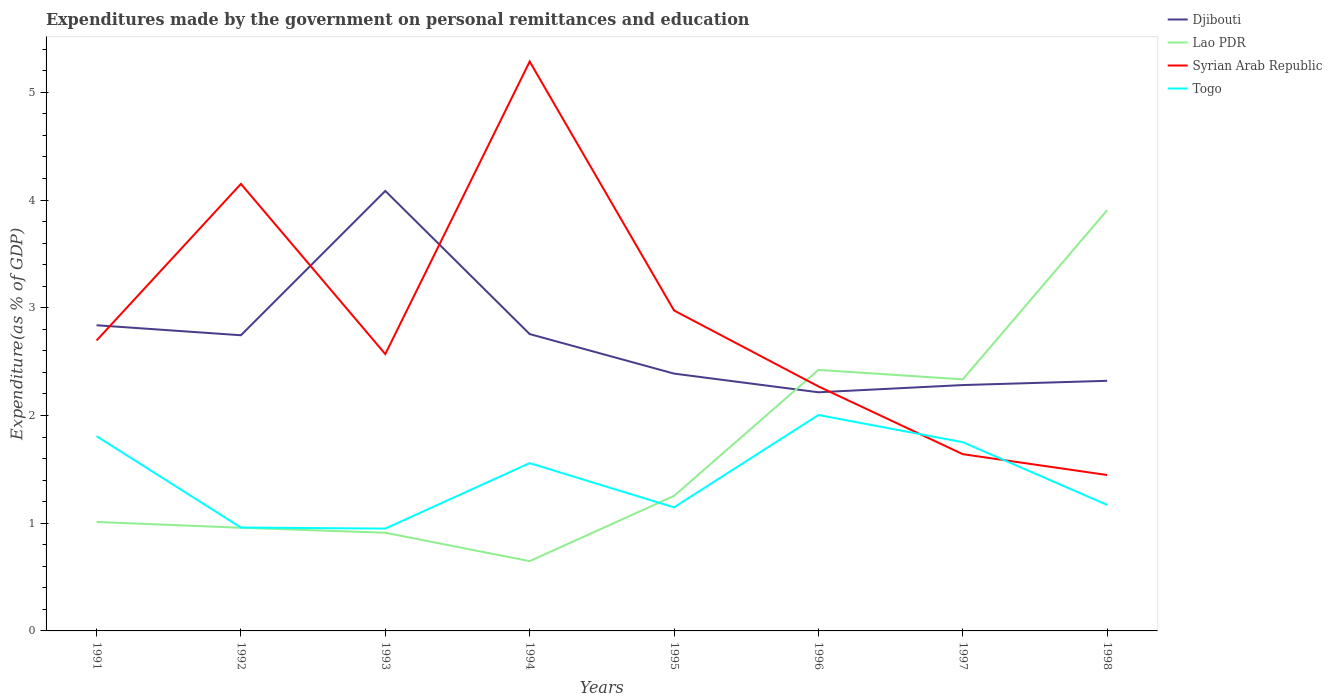How many different coloured lines are there?
Offer a terse response. 4. Across all years, what is the maximum expenditures made by the government on personal remittances and education in Djibouti?
Your response must be concise. 2.22. In which year was the expenditures made by the government on personal remittances and education in Syrian Arab Republic maximum?
Give a very brief answer. 1998. What is the total expenditures made by the government on personal remittances and education in Djibouti in the graph?
Provide a succinct answer. -0.01. What is the difference between the highest and the second highest expenditures made by the government on personal remittances and education in Syrian Arab Republic?
Keep it short and to the point. 3.84. What is the difference between the highest and the lowest expenditures made by the government on personal remittances and education in Togo?
Your answer should be compact. 4. Does the graph contain any zero values?
Keep it short and to the point. No. Where does the legend appear in the graph?
Keep it short and to the point. Top right. How are the legend labels stacked?
Offer a very short reply. Vertical. What is the title of the graph?
Make the answer very short. Expenditures made by the government on personal remittances and education. What is the label or title of the X-axis?
Provide a succinct answer. Years. What is the label or title of the Y-axis?
Your answer should be compact. Expenditure(as % of GDP). What is the Expenditure(as % of GDP) of Djibouti in 1991?
Make the answer very short. 2.84. What is the Expenditure(as % of GDP) of Lao PDR in 1991?
Make the answer very short. 1.01. What is the Expenditure(as % of GDP) of Syrian Arab Republic in 1991?
Offer a terse response. 2.7. What is the Expenditure(as % of GDP) of Togo in 1991?
Offer a very short reply. 1.81. What is the Expenditure(as % of GDP) of Djibouti in 1992?
Your answer should be compact. 2.74. What is the Expenditure(as % of GDP) of Lao PDR in 1992?
Your response must be concise. 0.96. What is the Expenditure(as % of GDP) of Syrian Arab Republic in 1992?
Offer a terse response. 4.15. What is the Expenditure(as % of GDP) in Togo in 1992?
Provide a short and direct response. 0.96. What is the Expenditure(as % of GDP) in Djibouti in 1993?
Offer a terse response. 4.08. What is the Expenditure(as % of GDP) in Lao PDR in 1993?
Make the answer very short. 0.91. What is the Expenditure(as % of GDP) of Syrian Arab Republic in 1993?
Your response must be concise. 2.57. What is the Expenditure(as % of GDP) in Togo in 1993?
Make the answer very short. 0.95. What is the Expenditure(as % of GDP) in Djibouti in 1994?
Your answer should be very brief. 2.76. What is the Expenditure(as % of GDP) of Lao PDR in 1994?
Keep it short and to the point. 0.65. What is the Expenditure(as % of GDP) in Syrian Arab Republic in 1994?
Offer a terse response. 5.29. What is the Expenditure(as % of GDP) in Togo in 1994?
Offer a very short reply. 1.56. What is the Expenditure(as % of GDP) of Djibouti in 1995?
Your answer should be compact. 2.39. What is the Expenditure(as % of GDP) in Lao PDR in 1995?
Your response must be concise. 1.25. What is the Expenditure(as % of GDP) of Syrian Arab Republic in 1995?
Provide a succinct answer. 2.97. What is the Expenditure(as % of GDP) of Togo in 1995?
Your response must be concise. 1.15. What is the Expenditure(as % of GDP) of Djibouti in 1996?
Ensure brevity in your answer.  2.22. What is the Expenditure(as % of GDP) of Lao PDR in 1996?
Give a very brief answer. 2.42. What is the Expenditure(as % of GDP) in Syrian Arab Republic in 1996?
Keep it short and to the point. 2.27. What is the Expenditure(as % of GDP) of Togo in 1996?
Make the answer very short. 2. What is the Expenditure(as % of GDP) in Djibouti in 1997?
Your answer should be very brief. 2.28. What is the Expenditure(as % of GDP) of Lao PDR in 1997?
Your response must be concise. 2.34. What is the Expenditure(as % of GDP) of Syrian Arab Republic in 1997?
Provide a short and direct response. 1.64. What is the Expenditure(as % of GDP) of Togo in 1997?
Offer a very short reply. 1.75. What is the Expenditure(as % of GDP) in Djibouti in 1998?
Provide a succinct answer. 2.32. What is the Expenditure(as % of GDP) in Lao PDR in 1998?
Give a very brief answer. 3.91. What is the Expenditure(as % of GDP) of Syrian Arab Republic in 1998?
Make the answer very short. 1.45. What is the Expenditure(as % of GDP) in Togo in 1998?
Make the answer very short. 1.17. Across all years, what is the maximum Expenditure(as % of GDP) in Djibouti?
Ensure brevity in your answer.  4.08. Across all years, what is the maximum Expenditure(as % of GDP) in Lao PDR?
Make the answer very short. 3.91. Across all years, what is the maximum Expenditure(as % of GDP) of Syrian Arab Republic?
Your answer should be compact. 5.29. Across all years, what is the maximum Expenditure(as % of GDP) in Togo?
Make the answer very short. 2. Across all years, what is the minimum Expenditure(as % of GDP) in Djibouti?
Provide a short and direct response. 2.22. Across all years, what is the minimum Expenditure(as % of GDP) of Lao PDR?
Ensure brevity in your answer.  0.65. Across all years, what is the minimum Expenditure(as % of GDP) of Syrian Arab Republic?
Provide a succinct answer. 1.45. Across all years, what is the minimum Expenditure(as % of GDP) in Togo?
Provide a short and direct response. 0.95. What is the total Expenditure(as % of GDP) in Djibouti in the graph?
Offer a very short reply. 21.63. What is the total Expenditure(as % of GDP) in Lao PDR in the graph?
Provide a short and direct response. 13.45. What is the total Expenditure(as % of GDP) in Syrian Arab Republic in the graph?
Offer a very short reply. 23.03. What is the total Expenditure(as % of GDP) in Togo in the graph?
Offer a terse response. 11.35. What is the difference between the Expenditure(as % of GDP) of Djibouti in 1991 and that in 1992?
Your answer should be compact. 0.09. What is the difference between the Expenditure(as % of GDP) in Lao PDR in 1991 and that in 1992?
Your response must be concise. 0.05. What is the difference between the Expenditure(as % of GDP) of Syrian Arab Republic in 1991 and that in 1992?
Give a very brief answer. -1.45. What is the difference between the Expenditure(as % of GDP) in Togo in 1991 and that in 1992?
Provide a short and direct response. 0.85. What is the difference between the Expenditure(as % of GDP) of Djibouti in 1991 and that in 1993?
Offer a very short reply. -1.25. What is the difference between the Expenditure(as % of GDP) in Lao PDR in 1991 and that in 1993?
Provide a short and direct response. 0.1. What is the difference between the Expenditure(as % of GDP) of Syrian Arab Republic in 1991 and that in 1993?
Offer a terse response. 0.13. What is the difference between the Expenditure(as % of GDP) of Togo in 1991 and that in 1993?
Your response must be concise. 0.86. What is the difference between the Expenditure(as % of GDP) in Djibouti in 1991 and that in 1994?
Ensure brevity in your answer.  0.08. What is the difference between the Expenditure(as % of GDP) in Lao PDR in 1991 and that in 1994?
Provide a short and direct response. 0.36. What is the difference between the Expenditure(as % of GDP) of Syrian Arab Republic in 1991 and that in 1994?
Your response must be concise. -2.59. What is the difference between the Expenditure(as % of GDP) of Togo in 1991 and that in 1994?
Ensure brevity in your answer.  0.25. What is the difference between the Expenditure(as % of GDP) of Djibouti in 1991 and that in 1995?
Offer a terse response. 0.45. What is the difference between the Expenditure(as % of GDP) of Lao PDR in 1991 and that in 1995?
Offer a very short reply. -0.24. What is the difference between the Expenditure(as % of GDP) of Syrian Arab Republic in 1991 and that in 1995?
Offer a terse response. -0.28. What is the difference between the Expenditure(as % of GDP) of Togo in 1991 and that in 1995?
Give a very brief answer. 0.66. What is the difference between the Expenditure(as % of GDP) of Djibouti in 1991 and that in 1996?
Give a very brief answer. 0.62. What is the difference between the Expenditure(as % of GDP) in Lao PDR in 1991 and that in 1996?
Provide a short and direct response. -1.41. What is the difference between the Expenditure(as % of GDP) of Syrian Arab Republic in 1991 and that in 1996?
Provide a short and direct response. 0.43. What is the difference between the Expenditure(as % of GDP) in Togo in 1991 and that in 1996?
Give a very brief answer. -0.2. What is the difference between the Expenditure(as % of GDP) of Djibouti in 1991 and that in 1997?
Give a very brief answer. 0.56. What is the difference between the Expenditure(as % of GDP) in Lao PDR in 1991 and that in 1997?
Your answer should be very brief. -1.32. What is the difference between the Expenditure(as % of GDP) of Syrian Arab Republic in 1991 and that in 1997?
Provide a short and direct response. 1.06. What is the difference between the Expenditure(as % of GDP) in Togo in 1991 and that in 1997?
Give a very brief answer. 0.06. What is the difference between the Expenditure(as % of GDP) of Djibouti in 1991 and that in 1998?
Your response must be concise. 0.52. What is the difference between the Expenditure(as % of GDP) of Lao PDR in 1991 and that in 1998?
Your answer should be very brief. -2.89. What is the difference between the Expenditure(as % of GDP) in Syrian Arab Republic in 1991 and that in 1998?
Provide a short and direct response. 1.25. What is the difference between the Expenditure(as % of GDP) in Togo in 1991 and that in 1998?
Make the answer very short. 0.64. What is the difference between the Expenditure(as % of GDP) in Djibouti in 1992 and that in 1993?
Offer a terse response. -1.34. What is the difference between the Expenditure(as % of GDP) in Lao PDR in 1992 and that in 1993?
Your response must be concise. 0.05. What is the difference between the Expenditure(as % of GDP) in Syrian Arab Republic in 1992 and that in 1993?
Offer a very short reply. 1.58. What is the difference between the Expenditure(as % of GDP) in Togo in 1992 and that in 1993?
Offer a very short reply. 0.01. What is the difference between the Expenditure(as % of GDP) of Djibouti in 1992 and that in 1994?
Your response must be concise. -0.01. What is the difference between the Expenditure(as % of GDP) of Lao PDR in 1992 and that in 1994?
Offer a very short reply. 0.31. What is the difference between the Expenditure(as % of GDP) of Syrian Arab Republic in 1992 and that in 1994?
Give a very brief answer. -1.14. What is the difference between the Expenditure(as % of GDP) in Togo in 1992 and that in 1994?
Make the answer very short. -0.6. What is the difference between the Expenditure(as % of GDP) in Djibouti in 1992 and that in 1995?
Your answer should be very brief. 0.36. What is the difference between the Expenditure(as % of GDP) of Lao PDR in 1992 and that in 1995?
Your answer should be compact. -0.3. What is the difference between the Expenditure(as % of GDP) of Syrian Arab Republic in 1992 and that in 1995?
Offer a very short reply. 1.18. What is the difference between the Expenditure(as % of GDP) of Togo in 1992 and that in 1995?
Your answer should be compact. -0.19. What is the difference between the Expenditure(as % of GDP) of Djibouti in 1992 and that in 1996?
Offer a very short reply. 0.53. What is the difference between the Expenditure(as % of GDP) of Lao PDR in 1992 and that in 1996?
Give a very brief answer. -1.47. What is the difference between the Expenditure(as % of GDP) in Syrian Arab Republic in 1992 and that in 1996?
Offer a very short reply. 1.88. What is the difference between the Expenditure(as % of GDP) of Togo in 1992 and that in 1996?
Your response must be concise. -1.04. What is the difference between the Expenditure(as % of GDP) in Djibouti in 1992 and that in 1997?
Your answer should be very brief. 0.46. What is the difference between the Expenditure(as % of GDP) of Lao PDR in 1992 and that in 1997?
Keep it short and to the point. -1.38. What is the difference between the Expenditure(as % of GDP) in Syrian Arab Republic in 1992 and that in 1997?
Your answer should be very brief. 2.51. What is the difference between the Expenditure(as % of GDP) of Togo in 1992 and that in 1997?
Provide a short and direct response. -0.79. What is the difference between the Expenditure(as % of GDP) in Djibouti in 1992 and that in 1998?
Provide a succinct answer. 0.42. What is the difference between the Expenditure(as % of GDP) in Lao PDR in 1992 and that in 1998?
Make the answer very short. -2.95. What is the difference between the Expenditure(as % of GDP) of Syrian Arab Republic in 1992 and that in 1998?
Your response must be concise. 2.7. What is the difference between the Expenditure(as % of GDP) of Togo in 1992 and that in 1998?
Make the answer very short. -0.21. What is the difference between the Expenditure(as % of GDP) in Djibouti in 1993 and that in 1994?
Your answer should be compact. 1.33. What is the difference between the Expenditure(as % of GDP) of Lao PDR in 1993 and that in 1994?
Give a very brief answer. 0.26. What is the difference between the Expenditure(as % of GDP) of Syrian Arab Republic in 1993 and that in 1994?
Ensure brevity in your answer.  -2.72. What is the difference between the Expenditure(as % of GDP) of Togo in 1993 and that in 1994?
Give a very brief answer. -0.61. What is the difference between the Expenditure(as % of GDP) in Djibouti in 1993 and that in 1995?
Your answer should be compact. 1.7. What is the difference between the Expenditure(as % of GDP) in Lao PDR in 1993 and that in 1995?
Make the answer very short. -0.34. What is the difference between the Expenditure(as % of GDP) of Syrian Arab Republic in 1993 and that in 1995?
Your answer should be compact. -0.4. What is the difference between the Expenditure(as % of GDP) in Togo in 1993 and that in 1995?
Give a very brief answer. -0.2. What is the difference between the Expenditure(as % of GDP) of Djibouti in 1993 and that in 1996?
Your answer should be compact. 1.87. What is the difference between the Expenditure(as % of GDP) in Lao PDR in 1993 and that in 1996?
Offer a terse response. -1.51. What is the difference between the Expenditure(as % of GDP) in Syrian Arab Republic in 1993 and that in 1996?
Your answer should be compact. 0.3. What is the difference between the Expenditure(as % of GDP) of Togo in 1993 and that in 1996?
Make the answer very short. -1.05. What is the difference between the Expenditure(as % of GDP) of Djibouti in 1993 and that in 1997?
Your answer should be very brief. 1.8. What is the difference between the Expenditure(as % of GDP) in Lao PDR in 1993 and that in 1997?
Your answer should be compact. -1.42. What is the difference between the Expenditure(as % of GDP) in Syrian Arab Republic in 1993 and that in 1997?
Offer a terse response. 0.93. What is the difference between the Expenditure(as % of GDP) in Togo in 1993 and that in 1997?
Ensure brevity in your answer.  -0.8. What is the difference between the Expenditure(as % of GDP) in Djibouti in 1993 and that in 1998?
Ensure brevity in your answer.  1.76. What is the difference between the Expenditure(as % of GDP) in Lao PDR in 1993 and that in 1998?
Offer a very short reply. -2.99. What is the difference between the Expenditure(as % of GDP) of Syrian Arab Republic in 1993 and that in 1998?
Make the answer very short. 1.12. What is the difference between the Expenditure(as % of GDP) in Togo in 1993 and that in 1998?
Ensure brevity in your answer.  -0.22. What is the difference between the Expenditure(as % of GDP) in Djibouti in 1994 and that in 1995?
Make the answer very short. 0.37. What is the difference between the Expenditure(as % of GDP) of Lao PDR in 1994 and that in 1995?
Keep it short and to the point. -0.61. What is the difference between the Expenditure(as % of GDP) of Syrian Arab Republic in 1994 and that in 1995?
Give a very brief answer. 2.31. What is the difference between the Expenditure(as % of GDP) in Togo in 1994 and that in 1995?
Your response must be concise. 0.41. What is the difference between the Expenditure(as % of GDP) of Djibouti in 1994 and that in 1996?
Provide a short and direct response. 0.54. What is the difference between the Expenditure(as % of GDP) in Lao PDR in 1994 and that in 1996?
Ensure brevity in your answer.  -1.78. What is the difference between the Expenditure(as % of GDP) in Syrian Arab Republic in 1994 and that in 1996?
Offer a terse response. 3.02. What is the difference between the Expenditure(as % of GDP) of Togo in 1994 and that in 1996?
Your answer should be very brief. -0.45. What is the difference between the Expenditure(as % of GDP) in Djibouti in 1994 and that in 1997?
Provide a short and direct response. 0.47. What is the difference between the Expenditure(as % of GDP) in Lao PDR in 1994 and that in 1997?
Offer a terse response. -1.69. What is the difference between the Expenditure(as % of GDP) of Syrian Arab Republic in 1994 and that in 1997?
Offer a very short reply. 3.64. What is the difference between the Expenditure(as % of GDP) of Togo in 1994 and that in 1997?
Your answer should be compact. -0.19. What is the difference between the Expenditure(as % of GDP) of Djibouti in 1994 and that in 1998?
Ensure brevity in your answer.  0.43. What is the difference between the Expenditure(as % of GDP) of Lao PDR in 1994 and that in 1998?
Offer a very short reply. -3.26. What is the difference between the Expenditure(as % of GDP) of Syrian Arab Republic in 1994 and that in 1998?
Make the answer very short. 3.84. What is the difference between the Expenditure(as % of GDP) in Togo in 1994 and that in 1998?
Offer a terse response. 0.39. What is the difference between the Expenditure(as % of GDP) in Djibouti in 1995 and that in 1996?
Offer a terse response. 0.17. What is the difference between the Expenditure(as % of GDP) of Lao PDR in 1995 and that in 1996?
Your response must be concise. -1.17. What is the difference between the Expenditure(as % of GDP) in Syrian Arab Republic in 1995 and that in 1996?
Your answer should be very brief. 0.7. What is the difference between the Expenditure(as % of GDP) in Togo in 1995 and that in 1996?
Offer a very short reply. -0.86. What is the difference between the Expenditure(as % of GDP) in Djibouti in 1995 and that in 1997?
Keep it short and to the point. 0.11. What is the difference between the Expenditure(as % of GDP) of Lao PDR in 1995 and that in 1997?
Give a very brief answer. -1.08. What is the difference between the Expenditure(as % of GDP) in Syrian Arab Republic in 1995 and that in 1997?
Offer a very short reply. 1.33. What is the difference between the Expenditure(as % of GDP) in Togo in 1995 and that in 1997?
Give a very brief answer. -0.6. What is the difference between the Expenditure(as % of GDP) of Djibouti in 1995 and that in 1998?
Offer a terse response. 0.07. What is the difference between the Expenditure(as % of GDP) in Lao PDR in 1995 and that in 1998?
Your answer should be compact. -2.65. What is the difference between the Expenditure(as % of GDP) of Syrian Arab Republic in 1995 and that in 1998?
Provide a short and direct response. 1.53. What is the difference between the Expenditure(as % of GDP) in Togo in 1995 and that in 1998?
Provide a short and direct response. -0.02. What is the difference between the Expenditure(as % of GDP) of Djibouti in 1996 and that in 1997?
Offer a terse response. -0.07. What is the difference between the Expenditure(as % of GDP) in Lao PDR in 1996 and that in 1997?
Provide a succinct answer. 0.09. What is the difference between the Expenditure(as % of GDP) of Syrian Arab Republic in 1996 and that in 1997?
Your answer should be very brief. 0.63. What is the difference between the Expenditure(as % of GDP) of Togo in 1996 and that in 1997?
Your answer should be compact. 0.25. What is the difference between the Expenditure(as % of GDP) in Djibouti in 1996 and that in 1998?
Make the answer very short. -0.11. What is the difference between the Expenditure(as % of GDP) of Lao PDR in 1996 and that in 1998?
Make the answer very short. -1.48. What is the difference between the Expenditure(as % of GDP) of Syrian Arab Republic in 1996 and that in 1998?
Your answer should be compact. 0.82. What is the difference between the Expenditure(as % of GDP) in Togo in 1996 and that in 1998?
Your answer should be compact. 0.83. What is the difference between the Expenditure(as % of GDP) of Djibouti in 1997 and that in 1998?
Ensure brevity in your answer.  -0.04. What is the difference between the Expenditure(as % of GDP) of Lao PDR in 1997 and that in 1998?
Give a very brief answer. -1.57. What is the difference between the Expenditure(as % of GDP) in Syrian Arab Republic in 1997 and that in 1998?
Ensure brevity in your answer.  0.19. What is the difference between the Expenditure(as % of GDP) of Togo in 1997 and that in 1998?
Ensure brevity in your answer.  0.58. What is the difference between the Expenditure(as % of GDP) of Djibouti in 1991 and the Expenditure(as % of GDP) of Lao PDR in 1992?
Offer a terse response. 1.88. What is the difference between the Expenditure(as % of GDP) of Djibouti in 1991 and the Expenditure(as % of GDP) of Syrian Arab Republic in 1992?
Ensure brevity in your answer.  -1.31. What is the difference between the Expenditure(as % of GDP) in Djibouti in 1991 and the Expenditure(as % of GDP) in Togo in 1992?
Your answer should be very brief. 1.88. What is the difference between the Expenditure(as % of GDP) of Lao PDR in 1991 and the Expenditure(as % of GDP) of Syrian Arab Republic in 1992?
Offer a terse response. -3.14. What is the difference between the Expenditure(as % of GDP) in Lao PDR in 1991 and the Expenditure(as % of GDP) in Togo in 1992?
Your answer should be very brief. 0.05. What is the difference between the Expenditure(as % of GDP) of Syrian Arab Republic in 1991 and the Expenditure(as % of GDP) of Togo in 1992?
Provide a succinct answer. 1.74. What is the difference between the Expenditure(as % of GDP) in Djibouti in 1991 and the Expenditure(as % of GDP) in Lao PDR in 1993?
Your answer should be compact. 1.93. What is the difference between the Expenditure(as % of GDP) of Djibouti in 1991 and the Expenditure(as % of GDP) of Syrian Arab Republic in 1993?
Your answer should be very brief. 0.27. What is the difference between the Expenditure(as % of GDP) of Djibouti in 1991 and the Expenditure(as % of GDP) of Togo in 1993?
Give a very brief answer. 1.89. What is the difference between the Expenditure(as % of GDP) in Lao PDR in 1991 and the Expenditure(as % of GDP) in Syrian Arab Republic in 1993?
Keep it short and to the point. -1.56. What is the difference between the Expenditure(as % of GDP) in Lao PDR in 1991 and the Expenditure(as % of GDP) in Togo in 1993?
Your answer should be very brief. 0.06. What is the difference between the Expenditure(as % of GDP) in Syrian Arab Republic in 1991 and the Expenditure(as % of GDP) in Togo in 1993?
Provide a short and direct response. 1.75. What is the difference between the Expenditure(as % of GDP) in Djibouti in 1991 and the Expenditure(as % of GDP) in Lao PDR in 1994?
Provide a succinct answer. 2.19. What is the difference between the Expenditure(as % of GDP) of Djibouti in 1991 and the Expenditure(as % of GDP) of Syrian Arab Republic in 1994?
Offer a terse response. -2.45. What is the difference between the Expenditure(as % of GDP) of Djibouti in 1991 and the Expenditure(as % of GDP) of Togo in 1994?
Provide a succinct answer. 1.28. What is the difference between the Expenditure(as % of GDP) in Lao PDR in 1991 and the Expenditure(as % of GDP) in Syrian Arab Republic in 1994?
Offer a very short reply. -4.27. What is the difference between the Expenditure(as % of GDP) in Lao PDR in 1991 and the Expenditure(as % of GDP) in Togo in 1994?
Your response must be concise. -0.55. What is the difference between the Expenditure(as % of GDP) of Syrian Arab Republic in 1991 and the Expenditure(as % of GDP) of Togo in 1994?
Provide a succinct answer. 1.14. What is the difference between the Expenditure(as % of GDP) of Djibouti in 1991 and the Expenditure(as % of GDP) of Lao PDR in 1995?
Give a very brief answer. 1.58. What is the difference between the Expenditure(as % of GDP) of Djibouti in 1991 and the Expenditure(as % of GDP) of Syrian Arab Republic in 1995?
Ensure brevity in your answer.  -0.14. What is the difference between the Expenditure(as % of GDP) in Djibouti in 1991 and the Expenditure(as % of GDP) in Togo in 1995?
Offer a terse response. 1.69. What is the difference between the Expenditure(as % of GDP) of Lao PDR in 1991 and the Expenditure(as % of GDP) of Syrian Arab Republic in 1995?
Keep it short and to the point. -1.96. What is the difference between the Expenditure(as % of GDP) in Lao PDR in 1991 and the Expenditure(as % of GDP) in Togo in 1995?
Make the answer very short. -0.14. What is the difference between the Expenditure(as % of GDP) of Syrian Arab Republic in 1991 and the Expenditure(as % of GDP) of Togo in 1995?
Ensure brevity in your answer.  1.55. What is the difference between the Expenditure(as % of GDP) of Djibouti in 1991 and the Expenditure(as % of GDP) of Lao PDR in 1996?
Keep it short and to the point. 0.41. What is the difference between the Expenditure(as % of GDP) of Djibouti in 1991 and the Expenditure(as % of GDP) of Syrian Arab Republic in 1996?
Your answer should be compact. 0.57. What is the difference between the Expenditure(as % of GDP) in Lao PDR in 1991 and the Expenditure(as % of GDP) in Syrian Arab Republic in 1996?
Make the answer very short. -1.26. What is the difference between the Expenditure(as % of GDP) in Lao PDR in 1991 and the Expenditure(as % of GDP) in Togo in 1996?
Offer a very short reply. -0.99. What is the difference between the Expenditure(as % of GDP) of Syrian Arab Republic in 1991 and the Expenditure(as % of GDP) of Togo in 1996?
Provide a succinct answer. 0.69. What is the difference between the Expenditure(as % of GDP) of Djibouti in 1991 and the Expenditure(as % of GDP) of Lao PDR in 1997?
Make the answer very short. 0.5. What is the difference between the Expenditure(as % of GDP) in Djibouti in 1991 and the Expenditure(as % of GDP) in Syrian Arab Republic in 1997?
Keep it short and to the point. 1.2. What is the difference between the Expenditure(as % of GDP) of Djibouti in 1991 and the Expenditure(as % of GDP) of Togo in 1997?
Your answer should be compact. 1.09. What is the difference between the Expenditure(as % of GDP) in Lao PDR in 1991 and the Expenditure(as % of GDP) in Syrian Arab Republic in 1997?
Make the answer very short. -0.63. What is the difference between the Expenditure(as % of GDP) of Lao PDR in 1991 and the Expenditure(as % of GDP) of Togo in 1997?
Offer a terse response. -0.74. What is the difference between the Expenditure(as % of GDP) of Syrian Arab Republic in 1991 and the Expenditure(as % of GDP) of Togo in 1997?
Ensure brevity in your answer.  0.94. What is the difference between the Expenditure(as % of GDP) in Djibouti in 1991 and the Expenditure(as % of GDP) in Lao PDR in 1998?
Your response must be concise. -1.07. What is the difference between the Expenditure(as % of GDP) in Djibouti in 1991 and the Expenditure(as % of GDP) in Syrian Arab Republic in 1998?
Offer a terse response. 1.39. What is the difference between the Expenditure(as % of GDP) in Djibouti in 1991 and the Expenditure(as % of GDP) in Togo in 1998?
Your response must be concise. 1.67. What is the difference between the Expenditure(as % of GDP) in Lao PDR in 1991 and the Expenditure(as % of GDP) in Syrian Arab Republic in 1998?
Provide a short and direct response. -0.44. What is the difference between the Expenditure(as % of GDP) of Lao PDR in 1991 and the Expenditure(as % of GDP) of Togo in 1998?
Provide a succinct answer. -0.16. What is the difference between the Expenditure(as % of GDP) in Syrian Arab Republic in 1991 and the Expenditure(as % of GDP) in Togo in 1998?
Provide a succinct answer. 1.53. What is the difference between the Expenditure(as % of GDP) in Djibouti in 1992 and the Expenditure(as % of GDP) in Lao PDR in 1993?
Provide a short and direct response. 1.83. What is the difference between the Expenditure(as % of GDP) in Djibouti in 1992 and the Expenditure(as % of GDP) in Syrian Arab Republic in 1993?
Offer a very short reply. 0.17. What is the difference between the Expenditure(as % of GDP) in Djibouti in 1992 and the Expenditure(as % of GDP) in Togo in 1993?
Keep it short and to the point. 1.79. What is the difference between the Expenditure(as % of GDP) of Lao PDR in 1992 and the Expenditure(as % of GDP) of Syrian Arab Republic in 1993?
Ensure brevity in your answer.  -1.61. What is the difference between the Expenditure(as % of GDP) in Lao PDR in 1992 and the Expenditure(as % of GDP) in Togo in 1993?
Offer a terse response. 0.01. What is the difference between the Expenditure(as % of GDP) of Syrian Arab Republic in 1992 and the Expenditure(as % of GDP) of Togo in 1993?
Your answer should be very brief. 3.2. What is the difference between the Expenditure(as % of GDP) of Djibouti in 1992 and the Expenditure(as % of GDP) of Lao PDR in 1994?
Give a very brief answer. 2.1. What is the difference between the Expenditure(as % of GDP) in Djibouti in 1992 and the Expenditure(as % of GDP) in Syrian Arab Republic in 1994?
Offer a very short reply. -2.54. What is the difference between the Expenditure(as % of GDP) of Djibouti in 1992 and the Expenditure(as % of GDP) of Togo in 1994?
Ensure brevity in your answer.  1.19. What is the difference between the Expenditure(as % of GDP) in Lao PDR in 1992 and the Expenditure(as % of GDP) in Syrian Arab Republic in 1994?
Keep it short and to the point. -4.33. What is the difference between the Expenditure(as % of GDP) in Lao PDR in 1992 and the Expenditure(as % of GDP) in Togo in 1994?
Offer a very short reply. -0.6. What is the difference between the Expenditure(as % of GDP) in Syrian Arab Republic in 1992 and the Expenditure(as % of GDP) in Togo in 1994?
Make the answer very short. 2.59. What is the difference between the Expenditure(as % of GDP) in Djibouti in 1992 and the Expenditure(as % of GDP) in Lao PDR in 1995?
Offer a very short reply. 1.49. What is the difference between the Expenditure(as % of GDP) in Djibouti in 1992 and the Expenditure(as % of GDP) in Syrian Arab Republic in 1995?
Your answer should be compact. -0.23. What is the difference between the Expenditure(as % of GDP) of Djibouti in 1992 and the Expenditure(as % of GDP) of Togo in 1995?
Provide a short and direct response. 1.6. What is the difference between the Expenditure(as % of GDP) in Lao PDR in 1992 and the Expenditure(as % of GDP) in Syrian Arab Republic in 1995?
Make the answer very short. -2.02. What is the difference between the Expenditure(as % of GDP) in Lao PDR in 1992 and the Expenditure(as % of GDP) in Togo in 1995?
Provide a short and direct response. -0.19. What is the difference between the Expenditure(as % of GDP) in Syrian Arab Republic in 1992 and the Expenditure(as % of GDP) in Togo in 1995?
Your answer should be compact. 3. What is the difference between the Expenditure(as % of GDP) of Djibouti in 1992 and the Expenditure(as % of GDP) of Lao PDR in 1996?
Ensure brevity in your answer.  0.32. What is the difference between the Expenditure(as % of GDP) of Djibouti in 1992 and the Expenditure(as % of GDP) of Syrian Arab Republic in 1996?
Offer a terse response. 0.47. What is the difference between the Expenditure(as % of GDP) of Djibouti in 1992 and the Expenditure(as % of GDP) of Togo in 1996?
Keep it short and to the point. 0.74. What is the difference between the Expenditure(as % of GDP) in Lao PDR in 1992 and the Expenditure(as % of GDP) in Syrian Arab Republic in 1996?
Give a very brief answer. -1.31. What is the difference between the Expenditure(as % of GDP) in Lao PDR in 1992 and the Expenditure(as % of GDP) in Togo in 1996?
Ensure brevity in your answer.  -1.05. What is the difference between the Expenditure(as % of GDP) in Syrian Arab Republic in 1992 and the Expenditure(as % of GDP) in Togo in 1996?
Offer a terse response. 2.15. What is the difference between the Expenditure(as % of GDP) in Djibouti in 1992 and the Expenditure(as % of GDP) in Lao PDR in 1997?
Offer a terse response. 0.41. What is the difference between the Expenditure(as % of GDP) in Djibouti in 1992 and the Expenditure(as % of GDP) in Syrian Arab Republic in 1997?
Your answer should be compact. 1.1. What is the difference between the Expenditure(as % of GDP) of Lao PDR in 1992 and the Expenditure(as % of GDP) of Syrian Arab Republic in 1997?
Your answer should be very brief. -0.68. What is the difference between the Expenditure(as % of GDP) of Lao PDR in 1992 and the Expenditure(as % of GDP) of Togo in 1997?
Your answer should be very brief. -0.79. What is the difference between the Expenditure(as % of GDP) of Syrian Arab Republic in 1992 and the Expenditure(as % of GDP) of Togo in 1997?
Your answer should be very brief. 2.4. What is the difference between the Expenditure(as % of GDP) in Djibouti in 1992 and the Expenditure(as % of GDP) in Lao PDR in 1998?
Your answer should be compact. -1.16. What is the difference between the Expenditure(as % of GDP) in Djibouti in 1992 and the Expenditure(as % of GDP) in Syrian Arab Republic in 1998?
Keep it short and to the point. 1.3. What is the difference between the Expenditure(as % of GDP) in Djibouti in 1992 and the Expenditure(as % of GDP) in Togo in 1998?
Give a very brief answer. 1.57. What is the difference between the Expenditure(as % of GDP) in Lao PDR in 1992 and the Expenditure(as % of GDP) in Syrian Arab Republic in 1998?
Keep it short and to the point. -0.49. What is the difference between the Expenditure(as % of GDP) in Lao PDR in 1992 and the Expenditure(as % of GDP) in Togo in 1998?
Give a very brief answer. -0.21. What is the difference between the Expenditure(as % of GDP) of Syrian Arab Republic in 1992 and the Expenditure(as % of GDP) of Togo in 1998?
Ensure brevity in your answer.  2.98. What is the difference between the Expenditure(as % of GDP) of Djibouti in 1993 and the Expenditure(as % of GDP) of Lao PDR in 1994?
Your answer should be very brief. 3.44. What is the difference between the Expenditure(as % of GDP) in Djibouti in 1993 and the Expenditure(as % of GDP) in Syrian Arab Republic in 1994?
Provide a succinct answer. -1.2. What is the difference between the Expenditure(as % of GDP) of Djibouti in 1993 and the Expenditure(as % of GDP) of Togo in 1994?
Ensure brevity in your answer.  2.53. What is the difference between the Expenditure(as % of GDP) of Lao PDR in 1993 and the Expenditure(as % of GDP) of Syrian Arab Republic in 1994?
Offer a very short reply. -4.37. What is the difference between the Expenditure(as % of GDP) of Lao PDR in 1993 and the Expenditure(as % of GDP) of Togo in 1994?
Your response must be concise. -0.65. What is the difference between the Expenditure(as % of GDP) in Syrian Arab Republic in 1993 and the Expenditure(as % of GDP) in Togo in 1994?
Keep it short and to the point. 1.01. What is the difference between the Expenditure(as % of GDP) in Djibouti in 1993 and the Expenditure(as % of GDP) in Lao PDR in 1995?
Provide a succinct answer. 2.83. What is the difference between the Expenditure(as % of GDP) of Djibouti in 1993 and the Expenditure(as % of GDP) of Syrian Arab Republic in 1995?
Make the answer very short. 1.11. What is the difference between the Expenditure(as % of GDP) of Djibouti in 1993 and the Expenditure(as % of GDP) of Togo in 1995?
Provide a succinct answer. 2.94. What is the difference between the Expenditure(as % of GDP) of Lao PDR in 1993 and the Expenditure(as % of GDP) of Syrian Arab Republic in 1995?
Your answer should be compact. -2.06. What is the difference between the Expenditure(as % of GDP) in Lao PDR in 1993 and the Expenditure(as % of GDP) in Togo in 1995?
Give a very brief answer. -0.24. What is the difference between the Expenditure(as % of GDP) of Syrian Arab Republic in 1993 and the Expenditure(as % of GDP) of Togo in 1995?
Your answer should be very brief. 1.42. What is the difference between the Expenditure(as % of GDP) in Djibouti in 1993 and the Expenditure(as % of GDP) in Lao PDR in 1996?
Give a very brief answer. 1.66. What is the difference between the Expenditure(as % of GDP) in Djibouti in 1993 and the Expenditure(as % of GDP) in Syrian Arab Republic in 1996?
Give a very brief answer. 1.81. What is the difference between the Expenditure(as % of GDP) of Djibouti in 1993 and the Expenditure(as % of GDP) of Togo in 1996?
Offer a very short reply. 2.08. What is the difference between the Expenditure(as % of GDP) in Lao PDR in 1993 and the Expenditure(as % of GDP) in Syrian Arab Republic in 1996?
Provide a short and direct response. -1.36. What is the difference between the Expenditure(as % of GDP) of Lao PDR in 1993 and the Expenditure(as % of GDP) of Togo in 1996?
Your response must be concise. -1.09. What is the difference between the Expenditure(as % of GDP) of Syrian Arab Republic in 1993 and the Expenditure(as % of GDP) of Togo in 1996?
Offer a very short reply. 0.57. What is the difference between the Expenditure(as % of GDP) of Djibouti in 1993 and the Expenditure(as % of GDP) of Lao PDR in 1997?
Your response must be concise. 1.75. What is the difference between the Expenditure(as % of GDP) of Djibouti in 1993 and the Expenditure(as % of GDP) of Syrian Arab Republic in 1997?
Your answer should be very brief. 2.44. What is the difference between the Expenditure(as % of GDP) in Djibouti in 1993 and the Expenditure(as % of GDP) in Togo in 1997?
Your answer should be very brief. 2.33. What is the difference between the Expenditure(as % of GDP) of Lao PDR in 1993 and the Expenditure(as % of GDP) of Syrian Arab Republic in 1997?
Provide a succinct answer. -0.73. What is the difference between the Expenditure(as % of GDP) in Lao PDR in 1993 and the Expenditure(as % of GDP) in Togo in 1997?
Provide a succinct answer. -0.84. What is the difference between the Expenditure(as % of GDP) of Syrian Arab Republic in 1993 and the Expenditure(as % of GDP) of Togo in 1997?
Offer a very short reply. 0.82. What is the difference between the Expenditure(as % of GDP) of Djibouti in 1993 and the Expenditure(as % of GDP) of Lao PDR in 1998?
Offer a terse response. 0.18. What is the difference between the Expenditure(as % of GDP) of Djibouti in 1993 and the Expenditure(as % of GDP) of Syrian Arab Republic in 1998?
Make the answer very short. 2.64. What is the difference between the Expenditure(as % of GDP) in Djibouti in 1993 and the Expenditure(as % of GDP) in Togo in 1998?
Ensure brevity in your answer.  2.91. What is the difference between the Expenditure(as % of GDP) of Lao PDR in 1993 and the Expenditure(as % of GDP) of Syrian Arab Republic in 1998?
Offer a very short reply. -0.54. What is the difference between the Expenditure(as % of GDP) of Lao PDR in 1993 and the Expenditure(as % of GDP) of Togo in 1998?
Your answer should be very brief. -0.26. What is the difference between the Expenditure(as % of GDP) of Syrian Arab Republic in 1993 and the Expenditure(as % of GDP) of Togo in 1998?
Your answer should be compact. 1.4. What is the difference between the Expenditure(as % of GDP) in Djibouti in 1994 and the Expenditure(as % of GDP) in Lao PDR in 1995?
Keep it short and to the point. 1.5. What is the difference between the Expenditure(as % of GDP) of Djibouti in 1994 and the Expenditure(as % of GDP) of Syrian Arab Republic in 1995?
Your answer should be compact. -0.22. What is the difference between the Expenditure(as % of GDP) in Djibouti in 1994 and the Expenditure(as % of GDP) in Togo in 1995?
Make the answer very short. 1.61. What is the difference between the Expenditure(as % of GDP) in Lao PDR in 1994 and the Expenditure(as % of GDP) in Syrian Arab Republic in 1995?
Provide a short and direct response. -2.33. What is the difference between the Expenditure(as % of GDP) of Lao PDR in 1994 and the Expenditure(as % of GDP) of Togo in 1995?
Provide a short and direct response. -0.5. What is the difference between the Expenditure(as % of GDP) of Syrian Arab Republic in 1994 and the Expenditure(as % of GDP) of Togo in 1995?
Your answer should be compact. 4.14. What is the difference between the Expenditure(as % of GDP) in Djibouti in 1994 and the Expenditure(as % of GDP) in Lao PDR in 1996?
Offer a very short reply. 0.33. What is the difference between the Expenditure(as % of GDP) of Djibouti in 1994 and the Expenditure(as % of GDP) of Syrian Arab Republic in 1996?
Your answer should be compact. 0.49. What is the difference between the Expenditure(as % of GDP) of Djibouti in 1994 and the Expenditure(as % of GDP) of Togo in 1996?
Provide a succinct answer. 0.75. What is the difference between the Expenditure(as % of GDP) in Lao PDR in 1994 and the Expenditure(as % of GDP) in Syrian Arab Republic in 1996?
Give a very brief answer. -1.62. What is the difference between the Expenditure(as % of GDP) in Lao PDR in 1994 and the Expenditure(as % of GDP) in Togo in 1996?
Your answer should be very brief. -1.36. What is the difference between the Expenditure(as % of GDP) of Syrian Arab Republic in 1994 and the Expenditure(as % of GDP) of Togo in 1996?
Your answer should be very brief. 3.28. What is the difference between the Expenditure(as % of GDP) in Djibouti in 1994 and the Expenditure(as % of GDP) in Lao PDR in 1997?
Give a very brief answer. 0.42. What is the difference between the Expenditure(as % of GDP) of Djibouti in 1994 and the Expenditure(as % of GDP) of Syrian Arab Republic in 1997?
Offer a very short reply. 1.11. What is the difference between the Expenditure(as % of GDP) of Djibouti in 1994 and the Expenditure(as % of GDP) of Togo in 1997?
Your answer should be compact. 1. What is the difference between the Expenditure(as % of GDP) in Lao PDR in 1994 and the Expenditure(as % of GDP) in Syrian Arab Republic in 1997?
Your answer should be compact. -0.99. What is the difference between the Expenditure(as % of GDP) in Lao PDR in 1994 and the Expenditure(as % of GDP) in Togo in 1997?
Offer a terse response. -1.1. What is the difference between the Expenditure(as % of GDP) in Syrian Arab Republic in 1994 and the Expenditure(as % of GDP) in Togo in 1997?
Provide a short and direct response. 3.53. What is the difference between the Expenditure(as % of GDP) in Djibouti in 1994 and the Expenditure(as % of GDP) in Lao PDR in 1998?
Make the answer very short. -1.15. What is the difference between the Expenditure(as % of GDP) in Djibouti in 1994 and the Expenditure(as % of GDP) in Syrian Arab Republic in 1998?
Ensure brevity in your answer.  1.31. What is the difference between the Expenditure(as % of GDP) of Djibouti in 1994 and the Expenditure(as % of GDP) of Togo in 1998?
Offer a very short reply. 1.59. What is the difference between the Expenditure(as % of GDP) in Lao PDR in 1994 and the Expenditure(as % of GDP) in Syrian Arab Republic in 1998?
Offer a very short reply. -0.8. What is the difference between the Expenditure(as % of GDP) in Lao PDR in 1994 and the Expenditure(as % of GDP) in Togo in 1998?
Your answer should be compact. -0.52. What is the difference between the Expenditure(as % of GDP) of Syrian Arab Republic in 1994 and the Expenditure(as % of GDP) of Togo in 1998?
Ensure brevity in your answer.  4.12. What is the difference between the Expenditure(as % of GDP) in Djibouti in 1995 and the Expenditure(as % of GDP) in Lao PDR in 1996?
Keep it short and to the point. -0.03. What is the difference between the Expenditure(as % of GDP) in Djibouti in 1995 and the Expenditure(as % of GDP) in Syrian Arab Republic in 1996?
Provide a succinct answer. 0.12. What is the difference between the Expenditure(as % of GDP) in Djibouti in 1995 and the Expenditure(as % of GDP) in Togo in 1996?
Provide a short and direct response. 0.38. What is the difference between the Expenditure(as % of GDP) of Lao PDR in 1995 and the Expenditure(as % of GDP) of Syrian Arab Republic in 1996?
Make the answer very short. -1.02. What is the difference between the Expenditure(as % of GDP) of Lao PDR in 1995 and the Expenditure(as % of GDP) of Togo in 1996?
Provide a succinct answer. -0.75. What is the difference between the Expenditure(as % of GDP) in Syrian Arab Republic in 1995 and the Expenditure(as % of GDP) in Togo in 1996?
Offer a very short reply. 0.97. What is the difference between the Expenditure(as % of GDP) of Djibouti in 1995 and the Expenditure(as % of GDP) of Lao PDR in 1997?
Provide a short and direct response. 0.05. What is the difference between the Expenditure(as % of GDP) in Djibouti in 1995 and the Expenditure(as % of GDP) in Syrian Arab Republic in 1997?
Offer a very short reply. 0.75. What is the difference between the Expenditure(as % of GDP) of Djibouti in 1995 and the Expenditure(as % of GDP) of Togo in 1997?
Ensure brevity in your answer.  0.64. What is the difference between the Expenditure(as % of GDP) of Lao PDR in 1995 and the Expenditure(as % of GDP) of Syrian Arab Republic in 1997?
Offer a very short reply. -0.39. What is the difference between the Expenditure(as % of GDP) in Lao PDR in 1995 and the Expenditure(as % of GDP) in Togo in 1997?
Keep it short and to the point. -0.5. What is the difference between the Expenditure(as % of GDP) of Syrian Arab Republic in 1995 and the Expenditure(as % of GDP) of Togo in 1997?
Ensure brevity in your answer.  1.22. What is the difference between the Expenditure(as % of GDP) of Djibouti in 1995 and the Expenditure(as % of GDP) of Lao PDR in 1998?
Provide a short and direct response. -1.52. What is the difference between the Expenditure(as % of GDP) of Djibouti in 1995 and the Expenditure(as % of GDP) of Syrian Arab Republic in 1998?
Your answer should be very brief. 0.94. What is the difference between the Expenditure(as % of GDP) in Djibouti in 1995 and the Expenditure(as % of GDP) in Togo in 1998?
Your response must be concise. 1.22. What is the difference between the Expenditure(as % of GDP) in Lao PDR in 1995 and the Expenditure(as % of GDP) in Syrian Arab Republic in 1998?
Give a very brief answer. -0.19. What is the difference between the Expenditure(as % of GDP) of Lao PDR in 1995 and the Expenditure(as % of GDP) of Togo in 1998?
Provide a succinct answer. 0.08. What is the difference between the Expenditure(as % of GDP) of Syrian Arab Republic in 1995 and the Expenditure(as % of GDP) of Togo in 1998?
Ensure brevity in your answer.  1.8. What is the difference between the Expenditure(as % of GDP) of Djibouti in 1996 and the Expenditure(as % of GDP) of Lao PDR in 1997?
Make the answer very short. -0.12. What is the difference between the Expenditure(as % of GDP) of Djibouti in 1996 and the Expenditure(as % of GDP) of Syrian Arab Republic in 1997?
Your answer should be compact. 0.57. What is the difference between the Expenditure(as % of GDP) of Djibouti in 1996 and the Expenditure(as % of GDP) of Togo in 1997?
Give a very brief answer. 0.46. What is the difference between the Expenditure(as % of GDP) of Lao PDR in 1996 and the Expenditure(as % of GDP) of Syrian Arab Republic in 1997?
Provide a short and direct response. 0.78. What is the difference between the Expenditure(as % of GDP) of Lao PDR in 1996 and the Expenditure(as % of GDP) of Togo in 1997?
Ensure brevity in your answer.  0.67. What is the difference between the Expenditure(as % of GDP) in Syrian Arab Republic in 1996 and the Expenditure(as % of GDP) in Togo in 1997?
Your answer should be very brief. 0.52. What is the difference between the Expenditure(as % of GDP) in Djibouti in 1996 and the Expenditure(as % of GDP) in Lao PDR in 1998?
Ensure brevity in your answer.  -1.69. What is the difference between the Expenditure(as % of GDP) of Djibouti in 1996 and the Expenditure(as % of GDP) of Syrian Arab Republic in 1998?
Provide a short and direct response. 0.77. What is the difference between the Expenditure(as % of GDP) in Djibouti in 1996 and the Expenditure(as % of GDP) in Togo in 1998?
Provide a short and direct response. 1.05. What is the difference between the Expenditure(as % of GDP) in Lao PDR in 1996 and the Expenditure(as % of GDP) in Syrian Arab Republic in 1998?
Ensure brevity in your answer.  0.98. What is the difference between the Expenditure(as % of GDP) in Lao PDR in 1996 and the Expenditure(as % of GDP) in Togo in 1998?
Provide a short and direct response. 1.25. What is the difference between the Expenditure(as % of GDP) in Syrian Arab Republic in 1996 and the Expenditure(as % of GDP) in Togo in 1998?
Provide a short and direct response. 1.1. What is the difference between the Expenditure(as % of GDP) in Djibouti in 1997 and the Expenditure(as % of GDP) in Lao PDR in 1998?
Give a very brief answer. -1.62. What is the difference between the Expenditure(as % of GDP) of Djibouti in 1997 and the Expenditure(as % of GDP) of Syrian Arab Republic in 1998?
Offer a very short reply. 0.84. What is the difference between the Expenditure(as % of GDP) of Djibouti in 1997 and the Expenditure(as % of GDP) of Togo in 1998?
Your answer should be very brief. 1.11. What is the difference between the Expenditure(as % of GDP) of Lao PDR in 1997 and the Expenditure(as % of GDP) of Syrian Arab Republic in 1998?
Provide a short and direct response. 0.89. What is the difference between the Expenditure(as % of GDP) in Lao PDR in 1997 and the Expenditure(as % of GDP) in Togo in 1998?
Make the answer very short. 1.17. What is the difference between the Expenditure(as % of GDP) in Syrian Arab Republic in 1997 and the Expenditure(as % of GDP) in Togo in 1998?
Make the answer very short. 0.47. What is the average Expenditure(as % of GDP) in Djibouti per year?
Provide a short and direct response. 2.7. What is the average Expenditure(as % of GDP) of Lao PDR per year?
Make the answer very short. 1.68. What is the average Expenditure(as % of GDP) of Syrian Arab Republic per year?
Your response must be concise. 2.88. What is the average Expenditure(as % of GDP) in Togo per year?
Make the answer very short. 1.42. In the year 1991, what is the difference between the Expenditure(as % of GDP) in Djibouti and Expenditure(as % of GDP) in Lao PDR?
Offer a terse response. 1.83. In the year 1991, what is the difference between the Expenditure(as % of GDP) in Djibouti and Expenditure(as % of GDP) in Syrian Arab Republic?
Your response must be concise. 0.14. In the year 1991, what is the difference between the Expenditure(as % of GDP) of Djibouti and Expenditure(as % of GDP) of Togo?
Your answer should be compact. 1.03. In the year 1991, what is the difference between the Expenditure(as % of GDP) in Lao PDR and Expenditure(as % of GDP) in Syrian Arab Republic?
Your answer should be very brief. -1.68. In the year 1991, what is the difference between the Expenditure(as % of GDP) in Lao PDR and Expenditure(as % of GDP) in Togo?
Your answer should be compact. -0.8. In the year 1991, what is the difference between the Expenditure(as % of GDP) in Syrian Arab Republic and Expenditure(as % of GDP) in Togo?
Your answer should be compact. 0.89. In the year 1992, what is the difference between the Expenditure(as % of GDP) in Djibouti and Expenditure(as % of GDP) in Lao PDR?
Give a very brief answer. 1.79. In the year 1992, what is the difference between the Expenditure(as % of GDP) of Djibouti and Expenditure(as % of GDP) of Syrian Arab Republic?
Your answer should be compact. -1.41. In the year 1992, what is the difference between the Expenditure(as % of GDP) of Djibouti and Expenditure(as % of GDP) of Togo?
Your answer should be compact. 1.79. In the year 1992, what is the difference between the Expenditure(as % of GDP) in Lao PDR and Expenditure(as % of GDP) in Syrian Arab Republic?
Offer a very short reply. -3.19. In the year 1992, what is the difference between the Expenditure(as % of GDP) in Lao PDR and Expenditure(as % of GDP) in Togo?
Your answer should be very brief. -0. In the year 1992, what is the difference between the Expenditure(as % of GDP) in Syrian Arab Republic and Expenditure(as % of GDP) in Togo?
Give a very brief answer. 3.19. In the year 1993, what is the difference between the Expenditure(as % of GDP) in Djibouti and Expenditure(as % of GDP) in Lao PDR?
Provide a succinct answer. 3.17. In the year 1993, what is the difference between the Expenditure(as % of GDP) of Djibouti and Expenditure(as % of GDP) of Syrian Arab Republic?
Offer a very short reply. 1.51. In the year 1993, what is the difference between the Expenditure(as % of GDP) of Djibouti and Expenditure(as % of GDP) of Togo?
Provide a short and direct response. 3.13. In the year 1993, what is the difference between the Expenditure(as % of GDP) in Lao PDR and Expenditure(as % of GDP) in Syrian Arab Republic?
Your response must be concise. -1.66. In the year 1993, what is the difference between the Expenditure(as % of GDP) in Lao PDR and Expenditure(as % of GDP) in Togo?
Give a very brief answer. -0.04. In the year 1993, what is the difference between the Expenditure(as % of GDP) of Syrian Arab Republic and Expenditure(as % of GDP) of Togo?
Make the answer very short. 1.62. In the year 1994, what is the difference between the Expenditure(as % of GDP) of Djibouti and Expenditure(as % of GDP) of Lao PDR?
Offer a very short reply. 2.11. In the year 1994, what is the difference between the Expenditure(as % of GDP) of Djibouti and Expenditure(as % of GDP) of Syrian Arab Republic?
Make the answer very short. -2.53. In the year 1994, what is the difference between the Expenditure(as % of GDP) of Djibouti and Expenditure(as % of GDP) of Togo?
Give a very brief answer. 1.2. In the year 1994, what is the difference between the Expenditure(as % of GDP) of Lao PDR and Expenditure(as % of GDP) of Syrian Arab Republic?
Provide a succinct answer. -4.64. In the year 1994, what is the difference between the Expenditure(as % of GDP) of Lao PDR and Expenditure(as % of GDP) of Togo?
Keep it short and to the point. -0.91. In the year 1994, what is the difference between the Expenditure(as % of GDP) of Syrian Arab Republic and Expenditure(as % of GDP) of Togo?
Ensure brevity in your answer.  3.73. In the year 1995, what is the difference between the Expenditure(as % of GDP) of Djibouti and Expenditure(as % of GDP) of Lao PDR?
Give a very brief answer. 1.14. In the year 1995, what is the difference between the Expenditure(as % of GDP) in Djibouti and Expenditure(as % of GDP) in Syrian Arab Republic?
Make the answer very short. -0.59. In the year 1995, what is the difference between the Expenditure(as % of GDP) of Djibouti and Expenditure(as % of GDP) of Togo?
Your answer should be compact. 1.24. In the year 1995, what is the difference between the Expenditure(as % of GDP) in Lao PDR and Expenditure(as % of GDP) in Syrian Arab Republic?
Your answer should be very brief. -1.72. In the year 1995, what is the difference between the Expenditure(as % of GDP) of Lao PDR and Expenditure(as % of GDP) of Togo?
Make the answer very short. 0.11. In the year 1995, what is the difference between the Expenditure(as % of GDP) of Syrian Arab Republic and Expenditure(as % of GDP) of Togo?
Provide a short and direct response. 1.83. In the year 1996, what is the difference between the Expenditure(as % of GDP) of Djibouti and Expenditure(as % of GDP) of Lao PDR?
Ensure brevity in your answer.  -0.21. In the year 1996, what is the difference between the Expenditure(as % of GDP) of Djibouti and Expenditure(as % of GDP) of Syrian Arab Republic?
Keep it short and to the point. -0.05. In the year 1996, what is the difference between the Expenditure(as % of GDP) of Djibouti and Expenditure(as % of GDP) of Togo?
Keep it short and to the point. 0.21. In the year 1996, what is the difference between the Expenditure(as % of GDP) of Lao PDR and Expenditure(as % of GDP) of Syrian Arab Republic?
Your answer should be compact. 0.15. In the year 1996, what is the difference between the Expenditure(as % of GDP) of Lao PDR and Expenditure(as % of GDP) of Togo?
Give a very brief answer. 0.42. In the year 1996, what is the difference between the Expenditure(as % of GDP) of Syrian Arab Republic and Expenditure(as % of GDP) of Togo?
Your response must be concise. 0.27. In the year 1997, what is the difference between the Expenditure(as % of GDP) of Djibouti and Expenditure(as % of GDP) of Lao PDR?
Provide a succinct answer. -0.05. In the year 1997, what is the difference between the Expenditure(as % of GDP) of Djibouti and Expenditure(as % of GDP) of Syrian Arab Republic?
Give a very brief answer. 0.64. In the year 1997, what is the difference between the Expenditure(as % of GDP) of Djibouti and Expenditure(as % of GDP) of Togo?
Provide a short and direct response. 0.53. In the year 1997, what is the difference between the Expenditure(as % of GDP) in Lao PDR and Expenditure(as % of GDP) in Syrian Arab Republic?
Keep it short and to the point. 0.69. In the year 1997, what is the difference between the Expenditure(as % of GDP) in Lao PDR and Expenditure(as % of GDP) in Togo?
Your response must be concise. 0.58. In the year 1997, what is the difference between the Expenditure(as % of GDP) in Syrian Arab Republic and Expenditure(as % of GDP) in Togo?
Provide a short and direct response. -0.11. In the year 1998, what is the difference between the Expenditure(as % of GDP) in Djibouti and Expenditure(as % of GDP) in Lao PDR?
Provide a succinct answer. -1.58. In the year 1998, what is the difference between the Expenditure(as % of GDP) of Djibouti and Expenditure(as % of GDP) of Syrian Arab Republic?
Your response must be concise. 0.87. In the year 1998, what is the difference between the Expenditure(as % of GDP) of Djibouti and Expenditure(as % of GDP) of Togo?
Your response must be concise. 1.15. In the year 1998, what is the difference between the Expenditure(as % of GDP) in Lao PDR and Expenditure(as % of GDP) in Syrian Arab Republic?
Ensure brevity in your answer.  2.46. In the year 1998, what is the difference between the Expenditure(as % of GDP) of Lao PDR and Expenditure(as % of GDP) of Togo?
Offer a terse response. 2.74. In the year 1998, what is the difference between the Expenditure(as % of GDP) in Syrian Arab Republic and Expenditure(as % of GDP) in Togo?
Your answer should be compact. 0.28. What is the ratio of the Expenditure(as % of GDP) of Djibouti in 1991 to that in 1992?
Provide a short and direct response. 1.03. What is the ratio of the Expenditure(as % of GDP) in Lao PDR in 1991 to that in 1992?
Provide a short and direct response. 1.06. What is the ratio of the Expenditure(as % of GDP) of Syrian Arab Republic in 1991 to that in 1992?
Ensure brevity in your answer.  0.65. What is the ratio of the Expenditure(as % of GDP) of Togo in 1991 to that in 1992?
Ensure brevity in your answer.  1.88. What is the ratio of the Expenditure(as % of GDP) in Djibouti in 1991 to that in 1993?
Offer a very short reply. 0.69. What is the ratio of the Expenditure(as % of GDP) in Lao PDR in 1991 to that in 1993?
Provide a short and direct response. 1.11. What is the ratio of the Expenditure(as % of GDP) in Syrian Arab Republic in 1991 to that in 1993?
Your response must be concise. 1.05. What is the ratio of the Expenditure(as % of GDP) in Togo in 1991 to that in 1993?
Give a very brief answer. 1.9. What is the ratio of the Expenditure(as % of GDP) of Djibouti in 1991 to that in 1994?
Provide a succinct answer. 1.03. What is the ratio of the Expenditure(as % of GDP) of Lao PDR in 1991 to that in 1994?
Your response must be concise. 1.56. What is the ratio of the Expenditure(as % of GDP) of Syrian Arab Republic in 1991 to that in 1994?
Make the answer very short. 0.51. What is the ratio of the Expenditure(as % of GDP) of Togo in 1991 to that in 1994?
Your response must be concise. 1.16. What is the ratio of the Expenditure(as % of GDP) in Djibouti in 1991 to that in 1995?
Offer a terse response. 1.19. What is the ratio of the Expenditure(as % of GDP) in Lao PDR in 1991 to that in 1995?
Your answer should be compact. 0.81. What is the ratio of the Expenditure(as % of GDP) in Syrian Arab Republic in 1991 to that in 1995?
Your response must be concise. 0.91. What is the ratio of the Expenditure(as % of GDP) in Togo in 1991 to that in 1995?
Your response must be concise. 1.58. What is the ratio of the Expenditure(as % of GDP) in Djibouti in 1991 to that in 1996?
Your response must be concise. 1.28. What is the ratio of the Expenditure(as % of GDP) in Lao PDR in 1991 to that in 1996?
Provide a succinct answer. 0.42. What is the ratio of the Expenditure(as % of GDP) in Syrian Arab Republic in 1991 to that in 1996?
Provide a succinct answer. 1.19. What is the ratio of the Expenditure(as % of GDP) of Togo in 1991 to that in 1996?
Ensure brevity in your answer.  0.9. What is the ratio of the Expenditure(as % of GDP) of Djibouti in 1991 to that in 1997?
Offer a terse response. 1.24. What is the ratio of the Expenditure(as % of GDP) in Lao PDR in 1991 to that in 1997?
Keep it short and to the point. 0.43. What is the ratio of the Expenditure(as % of GDP) of Syrian Arab Republic in 1991 to that in 1997?
Your answer should be very brief. 1.64. What is the ratio of the Expenditure(as % of GDP) in Togo in 1991 to that in 1997?
Your answer should be compact. 1.03. What is the ratio of the Expenditure(as % of GDP) of Djibouti in 1991 to that in 1998?
Your answer should be compact. 1.22. What is the ratio of the Expenditure(as % of GDP) of Lao PDR in 1991 to that in 1998?
Make the answer very short. 0.26. What is the ratio of the Expenditure(as % of GDP) in Syrian Arab Republic in 1991 to that in 1998?
Ensure brevity in your answer.  1.86. What is the ratio of the Expenditure(as % of GDP) in Togo in 1991 to that in 1998?
Offer a very short reply. 1.55. What is the ratio of the Expenditure(as % of GDP) of Djibouti in 1992 to that in 1993?
Keep it short and to the point. 0.67. What is the ratio of the Expenditure(as % of GDP) of Lao PDR in 1992 to that in 1993?
Offer a terse response. 1.05. What is the ratio of the Expenditure(as % of GDP) of Syrian Arab Republic in 1992 to that in 1993?
Give a very brief answer. 1.61. What is the ratio of the Expenditure(as % of GDP) in Togo in 1992 to that in 1993?
Give a very brief answer. 1.01. What is the ratio of the Expenditure(as % of GDP) in Djibouti in 1992 to that in 1994?
Make the answer very short. 1. What is the ratio of the Expenditure(as % of GDP) of Lao PDR in 1992 to that in 1994?
Offer a very short reply. 1.48. What is the ratio of the Expenditure(as % of GDP) of Syrian Arab Republic in 1992 to that in 1994?
Your answer should be very brief. 0.79. What is the ratio of the Expenditure(as % of GDP) in Togo in 1992 to that in 1994?
Offer a very short reply. 0.62. What is the ratio of the Expenditure(as % of GDP) of Djibouti in 1992 to that in 1995?
Your response must be concise. 1.15. What is the ratio of the Expenditure(as % of GDP) of Lao PDR in 1992 to that in 1995?
Your answer should be compact. 0.76. What is the ratio of the Expenditure(as % of GDP) of Syrian Arab Republic in 1992 to that in 1995?
Provide a succinct answer. 1.4. What is the ratio of the Expenditure(as % of GDP) of Togo in 1992 to that in 1995?
Provide a succinct answer. 0.84. What is the ratio of the Expenditure(as % of GDP) of Djibouti in 1992 to that in 1996?
Your answer should be compact. 1.24. What is the ratio of the Expenditure(as % of GDP) in Lao PDR in 1992 to that in 1996?
Offer a very short reply. 0.4. What is the ratio of the Expenditure(as % of GDP) of Syrian Arab Republic in 1992 to that in 1996?
Your answer should be compact. 1.83. What is the ratio of the Expenditure(as % of GDP) of Togo in 1992 to that in 1996?
Keep it short and to the point. 0.48. What is the ratio of the Expenditure(as % of GDP) in Djibouti in 1992 to that in 1997?
Offer a very short reply. 1.2. What is the ratio of the Expenditure(as % of GDP) of Lao PDR in 1992 to that in 1997?
Ensure brevity in your answer.  0.41. What is the ratio of the Expenditure(as % of GDP) in Syrian Arab Republic in 1992 to that in 1997?
Your answer should be compact. 2.53. What is the ratio of the Expenditure(as % of GDP) of Togo in 1992 to that in 1997?
Your response must be concise. 0.55. What is the ratio of the Expenditure(as % of GDP) in Djibouti in 1992 to that in 1998?
Offer a very short reply. 1.18. What is the ratio of the Expenditure(as % of GDP) in Lao PDR in 1992 to that in 1998?
Your response must be concise. 0.25. What is the ratio of the Expenditure(as % of GDP) of Syrian Arab Republic in 1992 to that in 1998?
Make the answer very short. 2.87. What is the ratio of the Expenditure(as % of GDP) of Togo in 1992 to that in 1998?
Offer a very short reply. 0.82. What is the ratio of the Expenditure(as % of GDP) of Djibouti in 1993 to that in 1994?
Give a very brief answer. 1.48. What is the ratio of the Expenditure(as % of GDP) in Lao PDR in 1993 to that in 1994?
Your answer should be very brief. 1.41. What is the ratio of the Expenditure(as % of GDP) in Syrian Arab Republic in 1993 to that in 1994?
Provide a succinct answer. 0.49. What is the ratio of the Expenditure(as % of GDP) in Togo in 1993 to that in 1994?
Provide a short and direct response. 0.61. What is the ratio of the Expenditure(as % of GDP) in Djibouti in 1993 to that in 1995?
Make the answer very short. 1.71. What is the ratio of the Expenditure(as % of GDP) of Lao PDR in 1993 to that in 1995?
Give a very brief answer. 0.73. What is the ratio of the Expenditure(as % of GDP) in Syrian Arab Republic in 1993 to that in 1995?
Offer a very short reply. 0.86. What is the ratio of the Expenditure(as % of GDP) in Togo in 1993 to that in 1995?
Your answer should be very brief. 0.83. What is the ratio of the Expenditure(as % of GDP) in Djibouti in 1993 to that in 1996?
Your response must be concise. 1.84. What is the ratio of the Expenditure(as % of GDP) of Lao PDR in 1993 to that in 1996?
Provide a succinct answer. 0.38. What is the ratio of the Expenditure(as % of GDP) in Syrian Arab Republic in 1993 to that in 1996?
Your answer should be very brief. 1.13. What is the ratio of the Expenditure(as % of GDP) of Togo in 1993 to that in 1996?
Make the answer very short. 0.47. What is the ratio of the Expenditure(as % of GDP) in Djibouti in 1993 to that in 1997?
Offer a terse response. 1.79. What is the ratio of the Expenditure(as % of GDP) in Lao PDR in 1993 to that in 1997?
Keep it short and to the point. 0.39. What is the ratio of the Expenditure(as % of GDP) of Syrian Arab Republic in 1993 to that in 1997?
Your response must be concise. 1.57. What is the ratio of the Expenditure(as % of GDP) in Togo in 1993 to that in 1997?
Provide a short and direct response. 0.54. What is the ratio of the Expenditure(as % of GDP) of Djibouti in 1993 to that in 1998?
Offer a terse response. 1.76. What is the ratio of the Expenditure(as % of GDP) of Lao PDR in 1993 to that in 1998?
Your response must be concise. 0.23. What is the ratio of the Expenditure(as % of GDP) of Syrian Arab Republic in 1993 to that in 1998?
Provide a short and direct response. 1.78. What is the ratio of the Expenditure(as % of GDP) of Togo in 1993 to that in 1998?
Make the answer very short. 0.81. What is the ratio of the Expenditure(as % of GDP) in Djibouti in 1994 to that in 1995?
Provide a short and direct response. 1.15. What is the ratio of the Expenditure(as % of GDP) of Lao PDR in 1994 to that in 1995?
Offer a terse response. 0.52. What is the ratio of the Expenditure(as % of GDP) of Syrian Arab Republic in 1994 to that in 1995?
Ensure brevity in your answer.  1.78. What is the ratio of the Expenditure(as % of GDP) of Togo in 1994 to that in 1995?
Give a very brief answer. 1.36. What is the ratio of the Expenditure(as % of GDP) of Djibouti in 1994 to that in 1996?
Your answer should be compact. 1.24. What is the ratio of the Expenditure(as % of GDP) of Lao PDR in 1994 to that in 1996?
Give a very brief answer. 0.27. What is the ratio of the Expenditure(as % of GDP) of Syrian Arab Republic in 1994 to that in 1996?
Offer a very short reply. 2.33. What is the ratio of the Expenditure(as % of GDP) in Togo in 1994 to that in 1996?
Your answer should be very brief. 0.78. What is the ratio of the Expenditure(as % of GDP) in Djibouti in 1994 to that in 1997?
Your answer should be very brief. 1.21. What is the ratio of the Expenditure(as % of GDP) in Lao PDR in 1994 to that in 1997?
Your answer should be compact. 0.28. What is the ratio of the Expenditure(as % of GDP) of Syrian Arab Republic in 1994 to that in 1997?
Offer a terse response. 3.22. What is the ratio of the Expenditure(as % of GDP) in Togo in 1994 to that in 1997?
Offer a terse response. 0.89. What is the ratio of the Expenditure(as % of GDP) in Djibouti in 1994 to that in 1998?
Offer a terse response. 1.19. What is the ratio of the Expenditure(as % of GDP) in Lao PDR in 1994 to that in 1998?
Your answer should be very brief. 0.17. What is the ratio of the Expenditure(as % of GDP) of Syrian Arab Republic in 1994 to that in 1998?
Give a very brief answer. 3.65. What is the ratio of the Expenditure(as % of GDP) of Togo in 1994 to that in 1998?
Offer a very short reply. 1.33. What is the ratio of the Expenditure(as % of GDP) of Djibouti in 1995 to that in 1996?
Give a very brief answer. 1.08. What is the ratio of the Expenditure(as % of GDP) of Lao PDR in 1995 to that in 1996?
Keep it short and to the point. 0.52. What is the ratio of the Expenditure(as % of GDP) of Syrian Arab Republic in 1995 to that in 1996?
Give a very brief answer. 1.31. What is the ratio of the Expenditure(as % of GDP) in Togo in 1995 to that in 1996?
Your answer should be very brief. 0.57. What is the ratio of the Expenditure(as % of GDP) of Djibouti in 1995 to that in 1997?
Make the answer very short. 1.05. What is the ratio of the Expenditure(as % of GDP) of Lao PDR in 1995 to that in 1997?
Your response must be concise. 0.54. What is the ratio of the Expenditure(as % of GDP) in Syrian Arab Republic in 1995 to that in 1997?
Provide a succinct answer. 1.81. What is the ratio of the Expenditure(as % of GDP) in Togo in 1995 to that in 1997?
Provide a short and direct response. 0.65. What is the ratio of the Expenditure(as % of GDP) in Djibouti in 1995 to that in 1998?
Ensure brevity in your answer.  1.03. What is the ratio of the Expenditure(as % of GDP) of Lao PDR in 1995 to that in 1998?
Offer a very short reply. 0.32. What is the ratio of the Expenditure(as % of GDP) of Syrian Arab Republic in 1995 to that in 1998?
Your answer should be very brief. 2.06. What is the ratio of the Expenditure(as % of GDP) of Togo in 1995 to that in 1998?
Your answer should be compact. 0.98. What is the ratio of the Expenditure(as % of GDP) of Djibouti in 1996 to that in 1997?
Your response must be concise. 0.97. What is the ratio of the Expenditure(as % of GDP) of Lao PDR in 1996 to that in 1997?
Keep it short and to the point. 1.04. What is the ratio of the Expenditure(as % of GDP) in Syrian Arab Republic in 1996 to that in 1997?
Provide a short and direct response. 1.38. What is the ratio of the Expenditure(as % of GDP) in Togo in 1996 to that in 1997?
Provide a short and direct response. 1.14. What is the ratio of the Expenditure(as % of GDP) in Djibouti in 1996 to that in 1998?
Provide a succinct answer. 0.95. What is the ratio of the Expenditure(as % of GDP) in Lao PDR in 1996 to that in 1998?
Ensure brevity in your answer.  0.62. What is the ratio of the Expenditure(as % of GDP) in Syrian Arab Republic in 1996 to that in 1998?
Ensure brevity in your answer.  1.57. What is the ratio of the Expenditure(as % of GDP) in Togo in 1996 to that in 1998?
Your answer should be compact. 1.71. What is the ratio of the Expenditure(as % of GDP) of Djibouti in 1997 to that in 1998?
Offer a very short reply. 0.98. What is the ratio of the Expenditure(as % of GDP) of Lao PDR in 1997 to that in 1998?
Offer a terse response. 0.6. What is the ratio of the Expenditure(as % of GDP) of Syrian Arab Republic in 1997 to that in 1998?
Your response must be concise. 1.13. What is the ratio of the Expenditure(as % of GDP) of Togo in 1997 to that in 1998?
Offer a very short reply. 1.5. What is the difference between the highest and the second highest Expenditure(as % of GDP) in Djibouti?
Provide a succinct answer. 1.25. What is the difference between the highest and the second highest Expenditure(as % of GDP) in Lao PDR?
Your response must be concise. 1.48. What is the difference between the highest and the second highest Expenditure(as % of GDP) in Syrian Arab Republic?
Provide a short and direct response. 1.14. What is the difference between the highest and the second highest Expenditure(as % of GDP) of Togo?
Your answer should be compact. 0.2. What is the difference between the highest and the lowest Expenditure(as % of GDP) of Djibouti?
Your answer should be very brief. 1.87. What is the difference between the highest and the lowest Expenditure(as % of GDP) of Lao PDR?
Your response must be concise. 3.26. What is the difference between the highest and the lowest Expenditure(as % of GDP) in Syrian Arab Republic?
Ensure brevity in your answer.  3.84. What is the difference between the highest and the lowest Expenditure(as % of GDP) of Togo?
Provide a succinct answer. 1.05. 